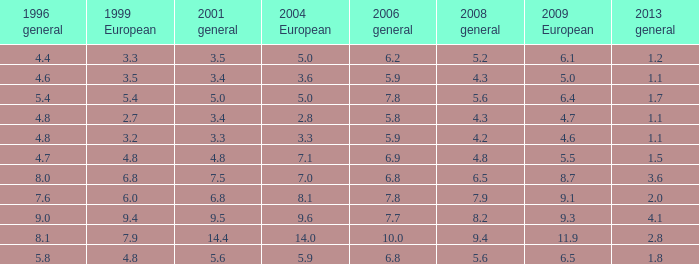3 in 2008 general? 3.6, 2.8. 